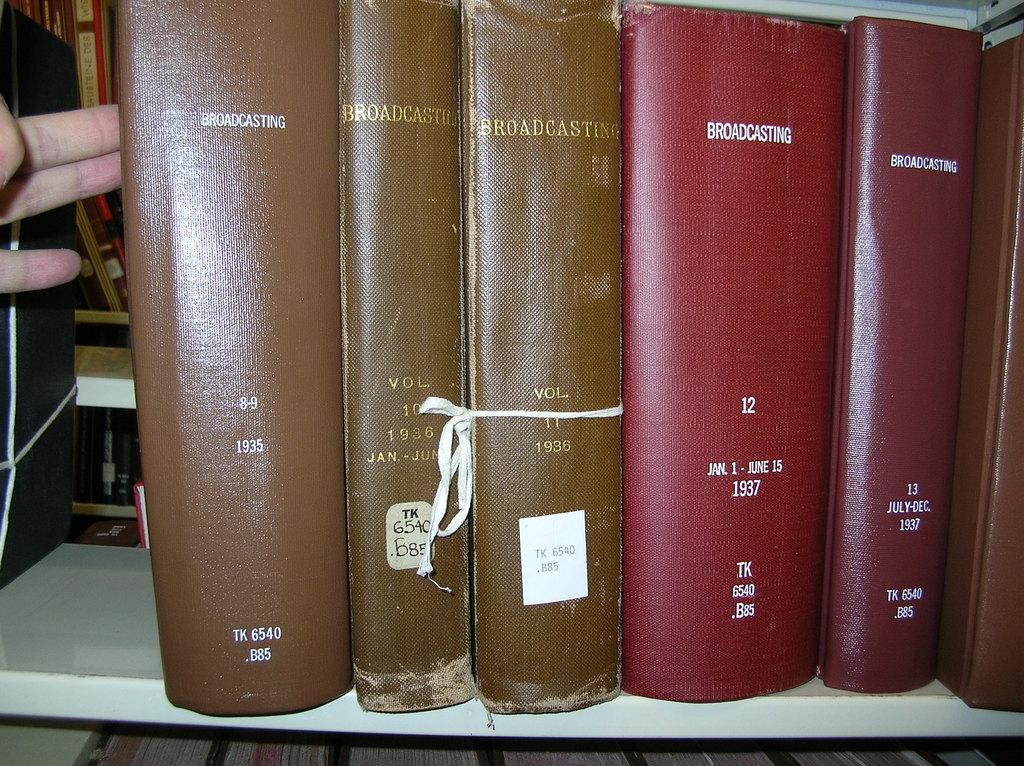What is the title of the red book in the image?
Your answer should be compact. Broadcasting. What is the right book called?
Your response must be concise. Broadcasting. 